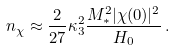Convert formula to latex. <formula><loc_0><loc_0><loc_500><loc_500>n _ { \chi } \approx \frac { 2 } { 2 7 } \kappa _ { 3 } ^ { 2 } \frac { M _ { \ast } ^ { 2 } | \chi ( 0 ) | ^ { 2 } } { H _ { 0 } } \, .</formula> 